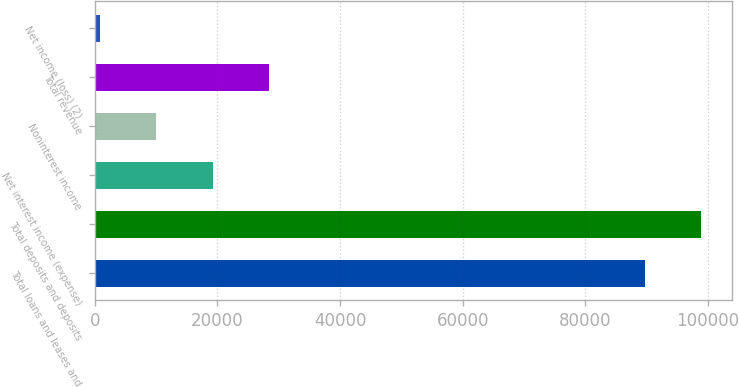<chart> <loc_0><loc_0><loc_500><loc_500><bar_chart><fcel>Total loans and leases and<fcel>Total deposits and deposits<fcel>Net interest income (expense)<fcel>Noninterest income<fcel>Total revenue<fcel>Net income (loss) (2)<nl><fcel>89744<fcel>98914<fcel>19205<fcel>10035<fcel>28375<fcel>865<nl></chart> 